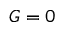<formula> <loc_0><loc_0><loc_500><loc_500>G = 0</formula> 